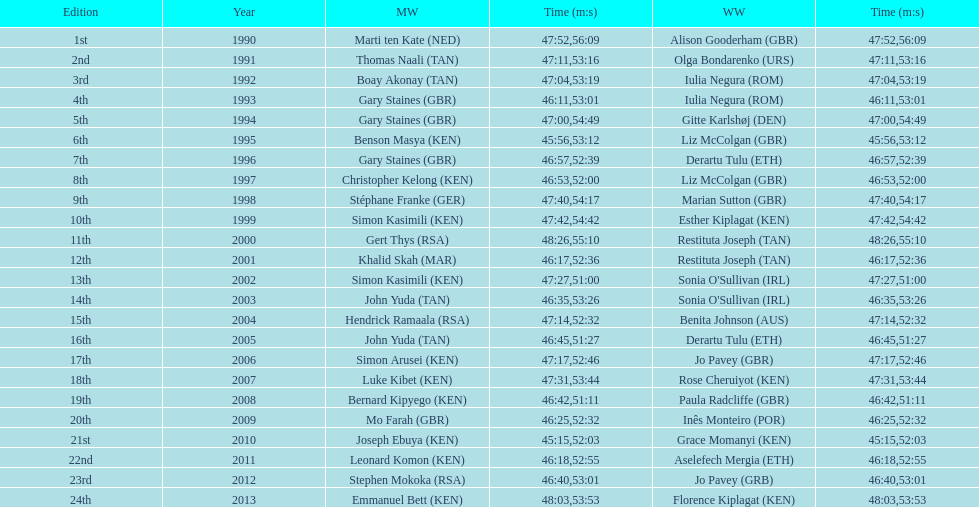Where any women faster than any men? No. 